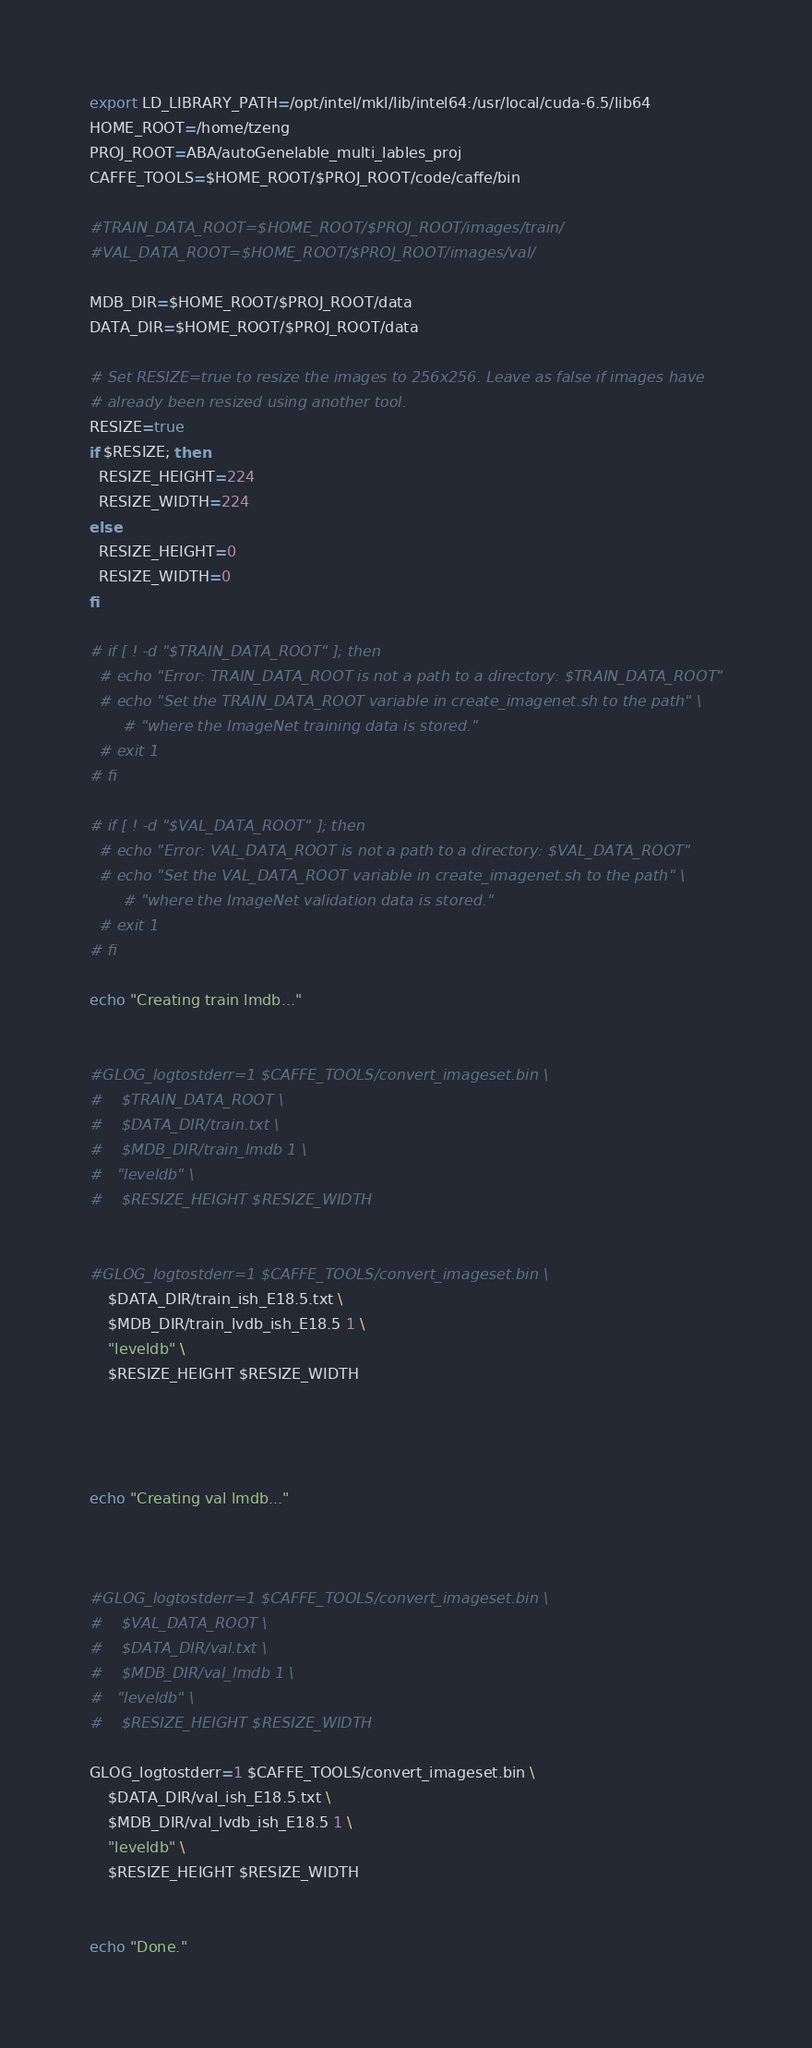Convert code to text. <code><loc_0><loc_0><loc_500><loc_500><_Bash_>export LD_LIBRARY_PATH=/opt/intel/mkl/lib/intel64:/usr/local/cuda-6.5/lib64
HOME_ROOT=/home/tzeng
PROJ_ROOT=ABA/autoGenelable_multi_lables_proj
CAFFE_TOOLS=$HOME_ROOT/$PROJ_ROOT/code/caffe/bin

#TRAIN_DATA_ROOT=$HOME_ROOT/$PROJ_ROOT/images/train/
#VAL_DATA_ROOT=$HOME_ROOT/$PROJ_ROOT/images/val/

MDB_DIR=$HOME_ROOT/$PROJ_ROOT/data
DATA_DIR=$HOME_ROOT/$PROJ_ROOT/data

# Set RESIZE=true to resize the images to 256x256. Leave as false if images have
# already been resized using another tool.
RESIZE=true
if $RESIZE; then
  RESIZE_HEIGHT=224
  RESIZE_WIDTH=224
else
  RESIZE_HEIGHT=0
  RESIZE_WIDTH=0
fi

# if [ ! -d "$TRAIN_DATA_ROOT" ]; then
  # echo "Error: TRAIN_DATA_ROOT is not a path to a directory: $TRAIN_DATA_ROOT"
  # echo "Set the TRAIN_DATA_ROOT variable in create_imagenet.sh to the path" \
       # "where the ImageNet training data is stored."
  # exit 1
# fi

# if [ ! -d "$VAL_DATA_ROOT" ]; then
  # echo "Error: VAL_DATA_ROOT is not a path to a directory: $VAL_DATA_ROOT"
  # echo "Set the VAL_DATA_ROOT variable in create_imagenet.sh to the path" \
       # "where the ImageNet validation data is stored."
  # exit 1
# fi

echo "Creating train lmdb..."


#GLOG_logtostderr=1 $CAFFE_TOOLS/convert_imageset.bin \
#    $TRAIN_DATA_ROOT \
#    $DATA_DIR/train.txt \
#    $MDB_DIR/train_lmdb 1 \
#	"leveldb" \
#    $RESIZE_HEIGHT $RESIZE_WIDTH


#GLOG_logtostderr=1 $CAFFE_TOOLS/convert_imageset.bin \
    $DATA_DIR/train_ish_E18.5.txt \
    $MDB_DIR/train_lvdb_ish_E18.5 1 \
	"leveldb" \
    $RESIZE_HEIGHT $RESIZE_WIDTH




echo "Creating val lmdb..."


	
#GLOG_logtostderr=1 $CAFFE_TOOLS/convert_imageset.bin \
#    $VAL_DATA_ROOT \
#    $DATA_DIR/val.txt \
#    $MDB_DIR/val_lmdb 1 \
#	"leveldb" \
#    $RESIZE_HEIGHT $RESIZE_WIDTH
	
GLOG_logtostderr=1 $CAFFE_TOOLS/convert_imageset.bin \
    $DATA_DIR/val_ish_E18.5.txt \
    $MDB_DIR/val_lvdb_ish_E18.5 1 \
	"leveldb" \
    $RESIZE_HEIGHT $RESIZE_WIDTH


echo "Done."</code> 